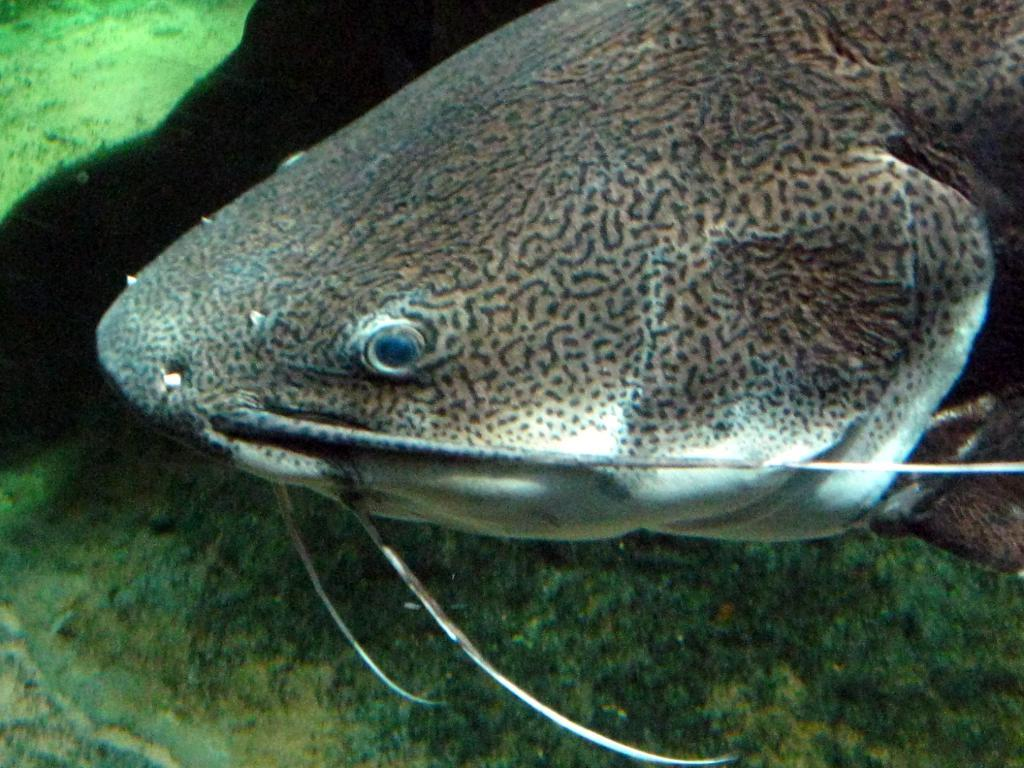What is the focus of the image? The image is zoomed in on a marine creature. Can you describe the marine creature in the center of the image? The marine creature appears to be a fish. What can be seen in the background of the image? There is a water body visible in the background of the image. What type of drink is being served in the image? There is no drink present in the image; it features a fish in a water body. What kind of metal object can be seen in the image? There is no metal object present in the image. 